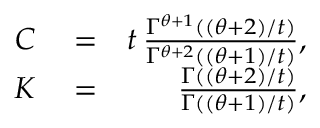<formula> <loc_0><loc_0><loc_500><loc_500>\begin{array} { r l r } { C } & = } & { t \, \frac { \Gamma ^ { \theta + 1 } ( ( \theta + 2 ) / t ) } { \Gamma ^ { \theta + 2 } ( ( \theta + 1 ) / t ) } , } \\ { K } & = } & { \frac { \Gamma ( ( \theta + 2 ) / t ) } { \Gamma ( ( \theta + 1 ) / t ) } , } \end{array}</formula> 